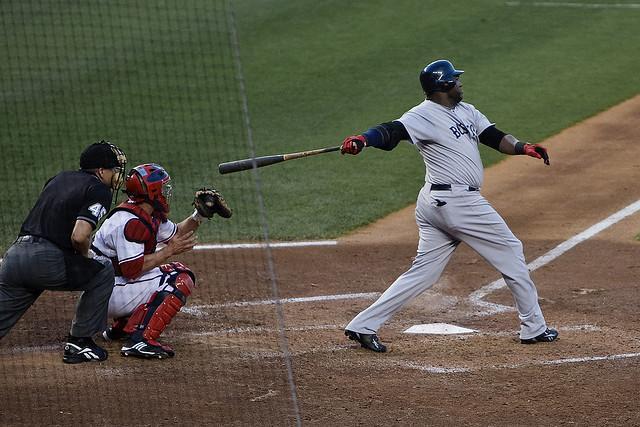How many people are in the picture?
Give a very brief answer. 3. 